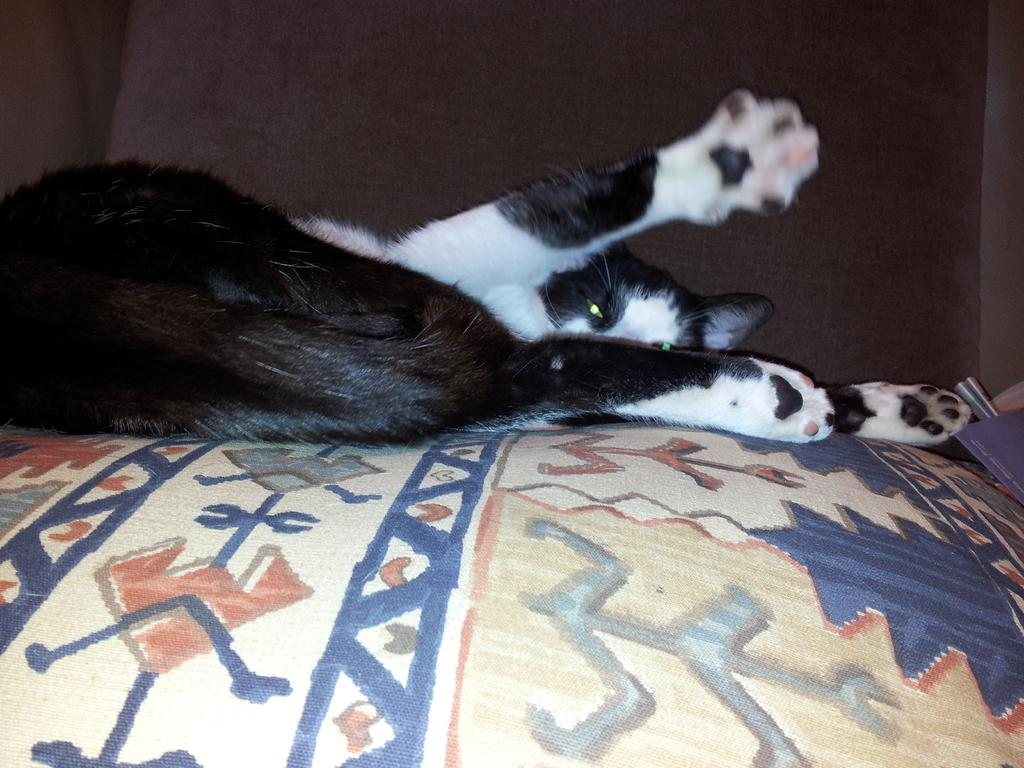What type of animal is in the image? There is a black and white cat in the image. What is the cat doing in the image? The cat is sleeping. Where is the cat resting in the image? The cat is on a pillow. What is the pillow resting on in the image? The pillow is on a bed. What can be seen in the background of the image? There is a wall in the background of the image. What type of mitten is the grandmother knitting in the image? There is no grandmother or knitting in the image; it features a black and white cat sleeping on a pillow. What does the cat taste like in the image? The image does not provide any information about the taste of the cat, as it is a visual representation. 